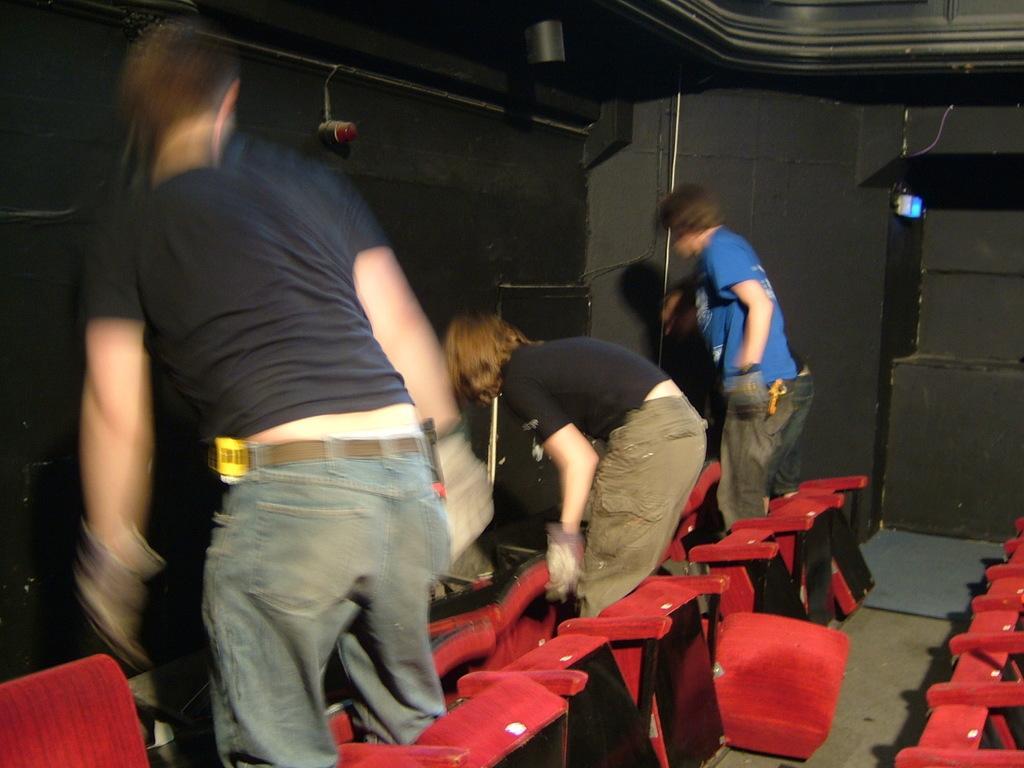In one or two sentences, can you explain what this image depicts? In this image, I can see three men standing. I think these are the chairs, which are red in color. At the top of the image, I can see the lights, which are attached to the wall. 